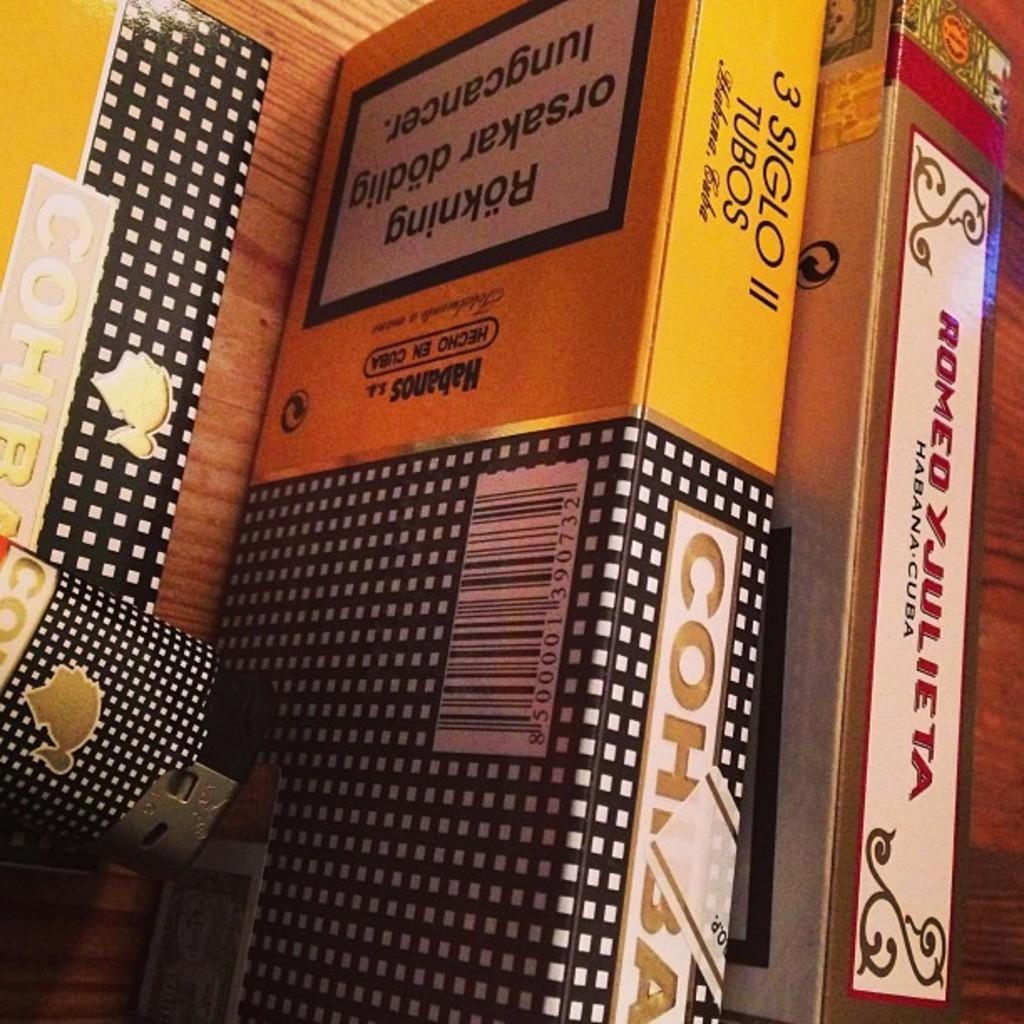Describe this image in one or two sentences. In this image there are books with different names and colors. And there are kept on a shelf. 